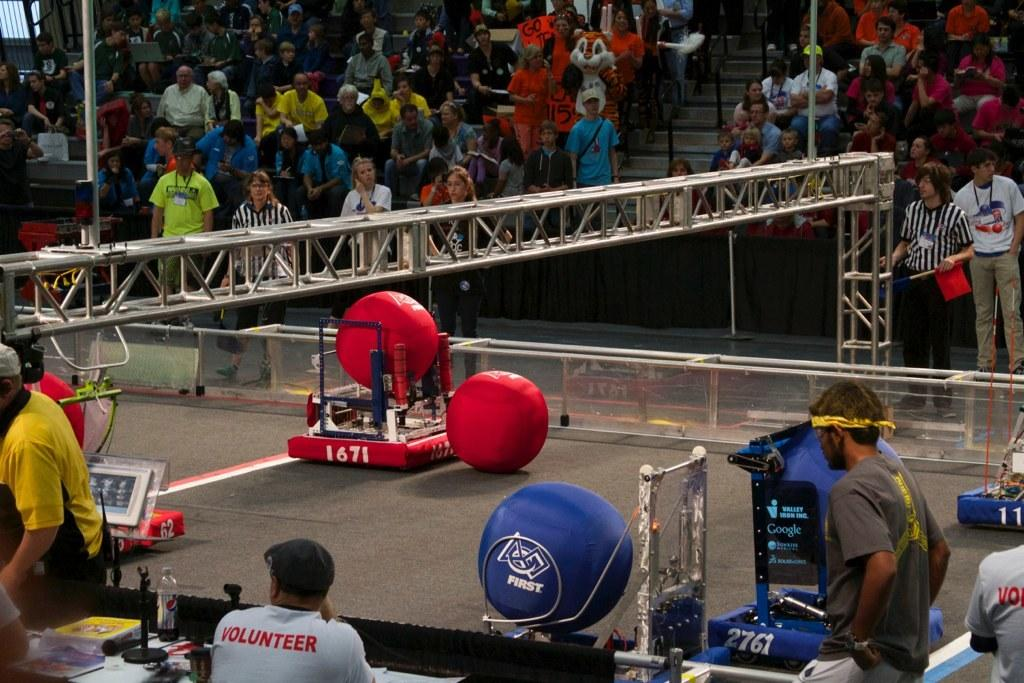What is happening in the image? There are many people sitting on chairs and standing in front of a play field. Where are the chairs located in the image? The chairs are located at the back of the image. What is in the middle of the image? There is a play field in the middle of the image. What are the people standing in front of? The people are standing in front of the play field. What type of vacation is being enjoyed by the people in the image? There is no indication of a vacation in the image; it simply shows people sitting on chairs and standing near a play field. What question is being asked by the person standing in front of the play field? There is no indication of a question being asked in the image; it only shows people standing near the play field. 